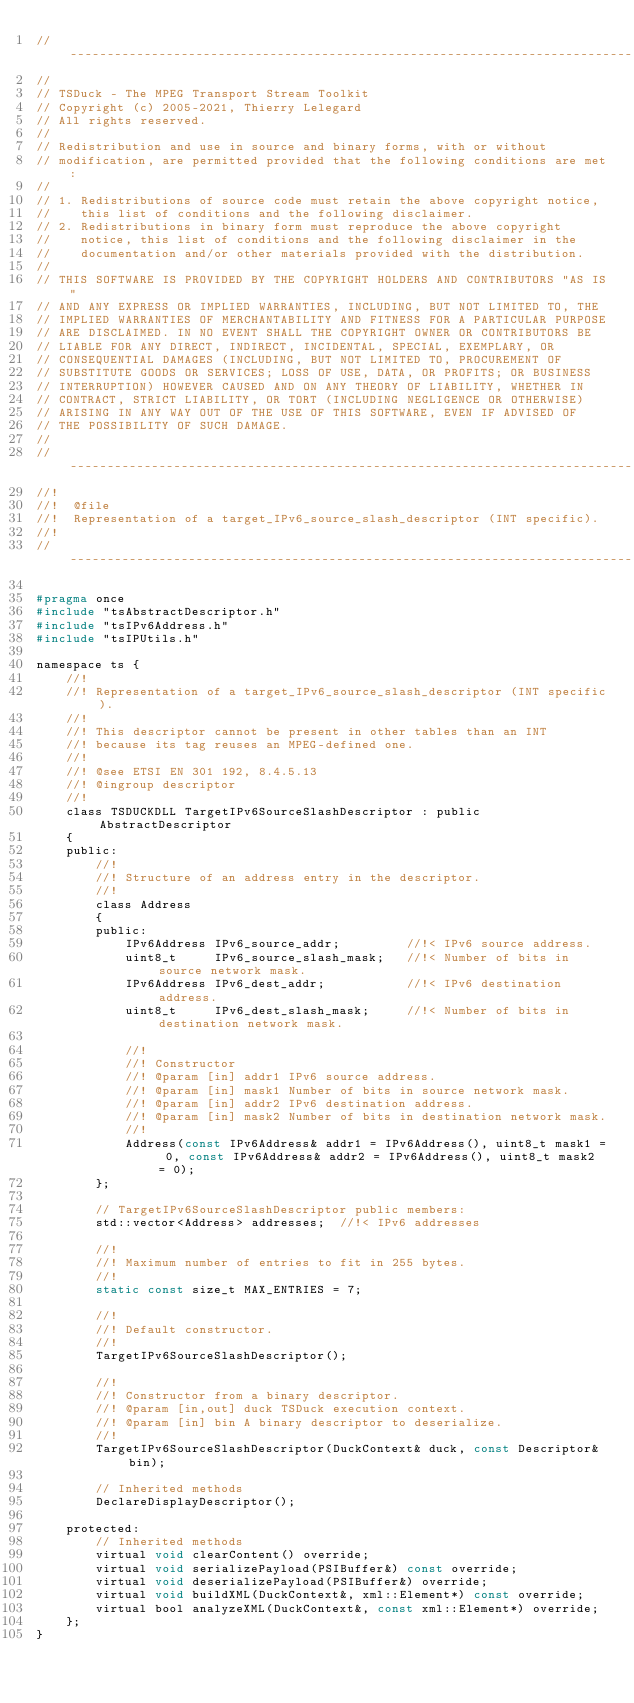Convert code to text. <code><loc_0><loc_0><loc_500><loc_500><_C_>//----------------------------------------------------------------------------
//
// TSDuck - The MPEG Transport Stream Toolkit
// Copyright (c) 2005-2021, Thierry Lelegard
// All rights reserved.
//
// Redistribution and use in source and binary forms, with or without
// modification, are permitted provided that the following conditions are met:
//
// 1. Redistributions of source code must retain the above copyright notice,
//    this list of conditions and the following disclaimer.
// 2. Redistributions in binary form must reproduce the above copyright
//    notice, this list of conditions and the following disclaimer in the
//    documentation and/or other materials provided with the distribution.
//
// THIS SOFTWARE IS PROVIDED BY THE COPYRIGHT HOLDERS AND CONTRIBUTORS "AS IS"
// AND ANY EXPRESS OR IMPLIED WARRANTIES, INCLUDING, BUT NOT LIMITED TO, THE
// IMPLIED WARRANTIES OF MERCHANTABILITY AND FITNESS FOR A PARTICULAR PURPOSE
// ARE DISCLAIMED. IN NO EVENT SHALL THE COPYRIGHT OWNER OR CONTRIBUTORS BE
// LIABLE FOR ANY DIRECT, INDIRECT, INCIDENTAL, SPECIAL, EXEMPLARY, OR
// CONSEQUENTIAL DAMAGES (INCLUDING, BUT NOT LIMITED TO, PROCUREMENT OF
// SUBSTITUTE GOODS OR SERVICES; LOSS OF USE, DATA, OR PROFITS; OR BUSINESS
// INTERRUPTION) HOWEVER CAUSED AND ON ANY THEORY OF LIABILITY, WHETHER IN
// CONTRACT, STRICT LIABILITY, OR TORT (INCLUDING NEGLIGENCE OR OTHERWISE)
// ARISING IN ANY WAY OUT OF THE USE OF THIS SOFTWARE, EVEN IF ADVISED OF
// THE POSSIBILITY OF SUCH DAMAGE.
//
//----------------------------------------------------------------------------
//!
//!  @file
//!  Representation of a target_IPv6_source_slash_descriptor (INT specific).
//!
//----------------------------------------------------------------------------

#pragma once
#include "tsAbstractDescriptor.h"
#include "tsIPv6Address.h"
#include "tsIPUtils.h"

namespace ts {
    //!
    //! Representation of a target_IPv6_source_slash_descriptor (INT specific).
    //!
    //! This descriptor cannot be present in other tables than an INT
    //! because its tag reuses an MPEG-defined one.
    //!
    //! @see ETSI EN 301 192, 8.4.5.13
    //! @ingroup descriptor
    //!
    class TSDUCKDLL TargetIPv6SourceSlashDescriptor : public AbstractDescriptor
    {
    public:
        //!
        //! Structure of an address entry in the descriptor.
        //!
        class Address
        {
        public:
            IPv6Address IPv6_source_addr;         //!< IPv6 source address.
            uint8_t     IPv6_source_slash_mask;   //!< Number of bits in source network mask.
            IPv6Address IPv6_dest_addr;           //!< IPv6 destination address.
            uint8_t     IPv6_dest_slash_mask;     //!< Number of bits in destination network mask.

            //!
            //! Constructor
            //! @param [in] addr1 IPv6 source address.
            //! @param [in] mask1 Number of bits in source network mask.
            //! @param [in] addr2 IPv6 destination address.
            //! @param [in] mask2 Number of bits in destination network mask.
            //!
            Address(const IPv6Address& addr1 = IPv6Address(), uint8_t mask1 = 0, const IPv6Address& addr2 = IPv6Address(), uint8_t mask2 = 0);
        };

        // TargetIPv6SourceSlashDescriptor public members:
        std::vector<Address> addresses;  //!< IPv6 addresses

        //!
        //! Maximum number of entries to fit in 255 bytes.
        //!
        static const size_t MAX_ENTRIES = 7;

        //!
        //! Default constructor.
        //!
        TargetIPv6SourceSlashDescriptor();

        //!
        //! Constructor from a binary descriptor.
        //! @param [in,out] duck TSDuck execution context.
        //! @param [in] bin A binary descriptor to deserialize.
        //!
        TargetIPv6SourceSlashDescriptor(DuckContext& duck, const Descriptor& bin);

        // Inherited methods
        DeclareDisplayDescriptor();

    protected:
        // Inherited methods
        virtual void clearContent() override;
        virtual void serializePayload(PSIBuffer&) const override;
        virtual void deserializePayload(PSIBuffer&) override;
        virtual void buildXML(DuckContext&, xml::Element*) const override;
        virtual bool analyzeXML(DuckContext&, const xml::Element*) override;
    };
}
</code> 